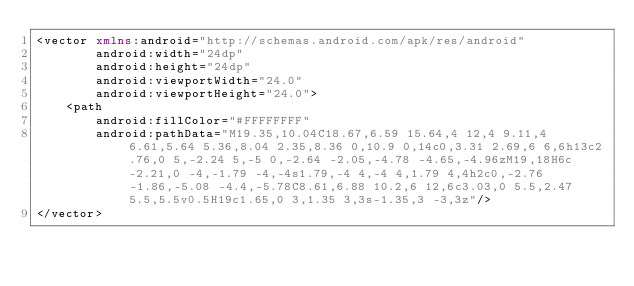<code> <loc_0><loc_0><loc_500><loc_500><_XML_><vector xmlns:android="http://schemas.android.com/apk/res/android"
        android:width="24dp"
        android:height="24dp"
        android:viewportWidth="24.0"
        android:viewportHeight="24.0">
    <path
        android:fillColor="#FFFFFFFF"
        android:pathData="M19.35,10.04C18.67,6.59 15.64,4 12,4 9.11,4 6.61,5.64 5.36,8.04 2.35,8.36 0,10.9 0,14c0,3.31 2.69,6 6,6h13c2.76,0 5,-2.24 5,-5 0,-2.64 -2.05,-4.78 -4.65,-4.96zM19,18H6c-2.21,0 -4,-1.79 -4,-4s1.79,-4 4,-4 4,1.79 4,4h2c0,-2.76 -1.86,-5.08 -4.4,-5.78C8.61,6.88 10.2,6 12,6c3.03,0 5.5,2.47 5.5,5.5v0.5H19c1.65,0 3,1.35 3,3s-1.35,3 -3,3z"/>
</vector>
</code> 